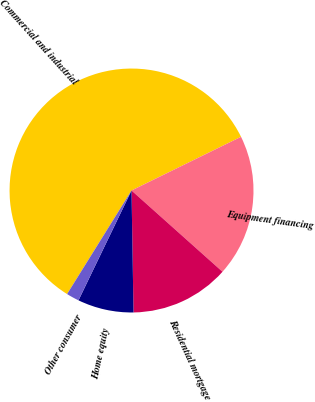Convert chart to OTSL. <chart><loc_0><loc_0><loc_500><loc_500><pie_chart><fcel>Commercial and industrial<fcel>Equipment financing<fcel>Residential mortgage<fcel>Home equity<fcel>Other consumer<nl><fcel>58.89%<fcel>18.86%<fcel>13.14%<fcel>7.42%<fcel>1.7%<nl></chart> 